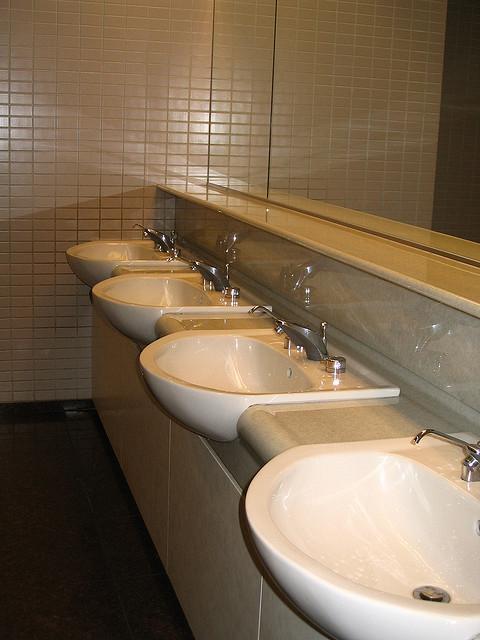How many sinks are there?
Give a very brief answer. 4. How many sinks can you see?
Give a very brief answer. 4. 